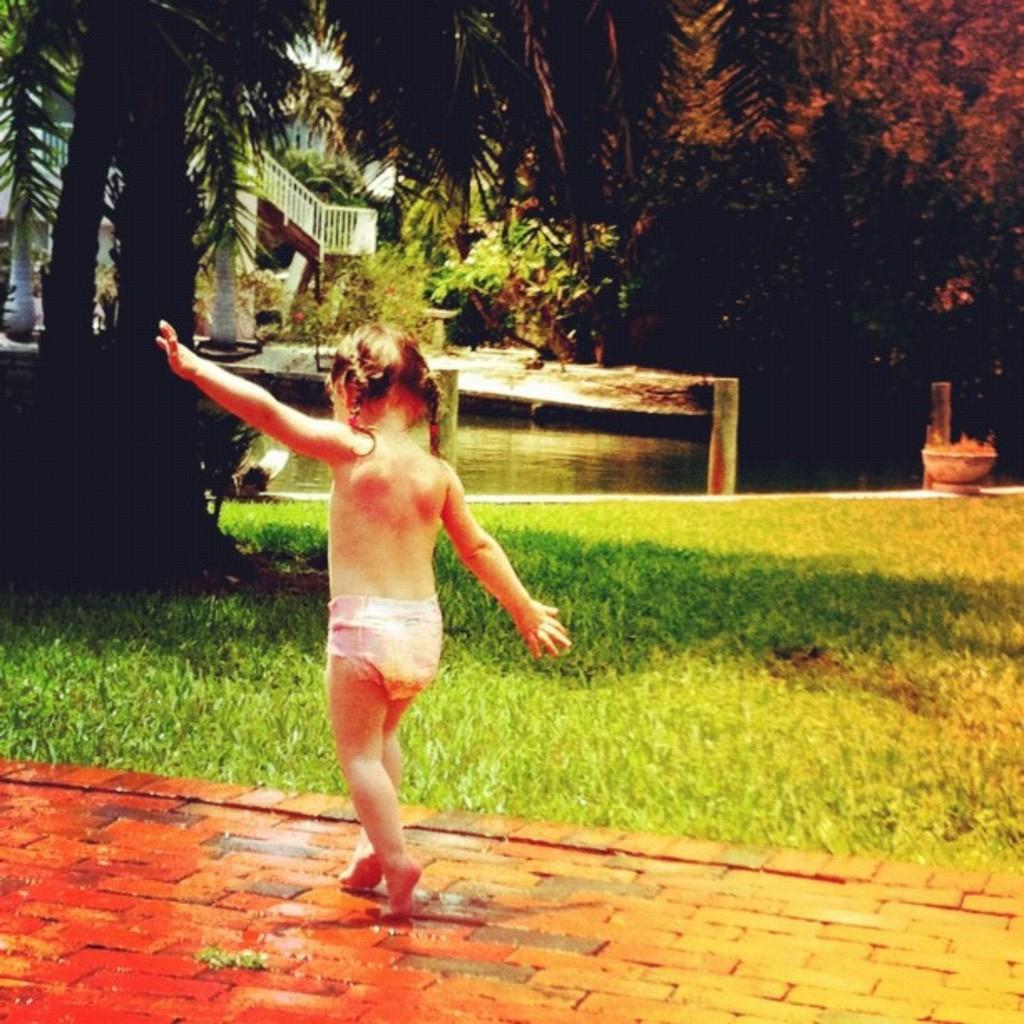How would you summarize this image in a sentence or two? In this image there is one girl who is walking, and at the bottom there is walkway and grass. And in the background there is a house, railing, trees, pond and and some objects. 